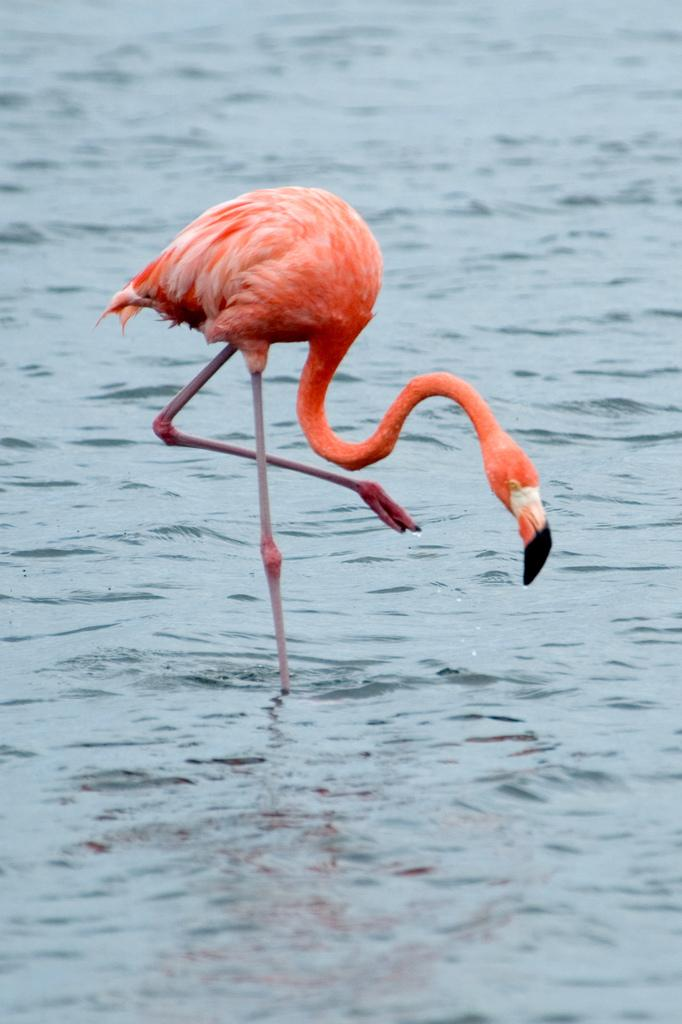What is the main subject of the image? There is a bird in the center of the image. Where is the bird located in relation to the water? The bird is standing in the water. Can you describe the background of the image? There is water visible in the background of the image. What type of noise can be heard coming from the bird in the image? There is no sound present in the image, so it is not possible to determine what noise, if any, might be heard. 